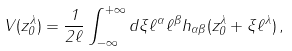Convert formula to latex. <formula><loc_0><loc_0><loc_500><loc_500>V ( z _ { 0 } ^ { \lambda } ) = \frac { 1 } { 2 \ell } \int _ { - \infty } ^ { + \infty } d \xi \ell ^ { \alpha } \ell ^ { \beta } h _ { \alpha \beta } ( z _ { 0 } ^ { \lambda } + \xi \ell ^ { \lambda } ) \, ,</formula> 